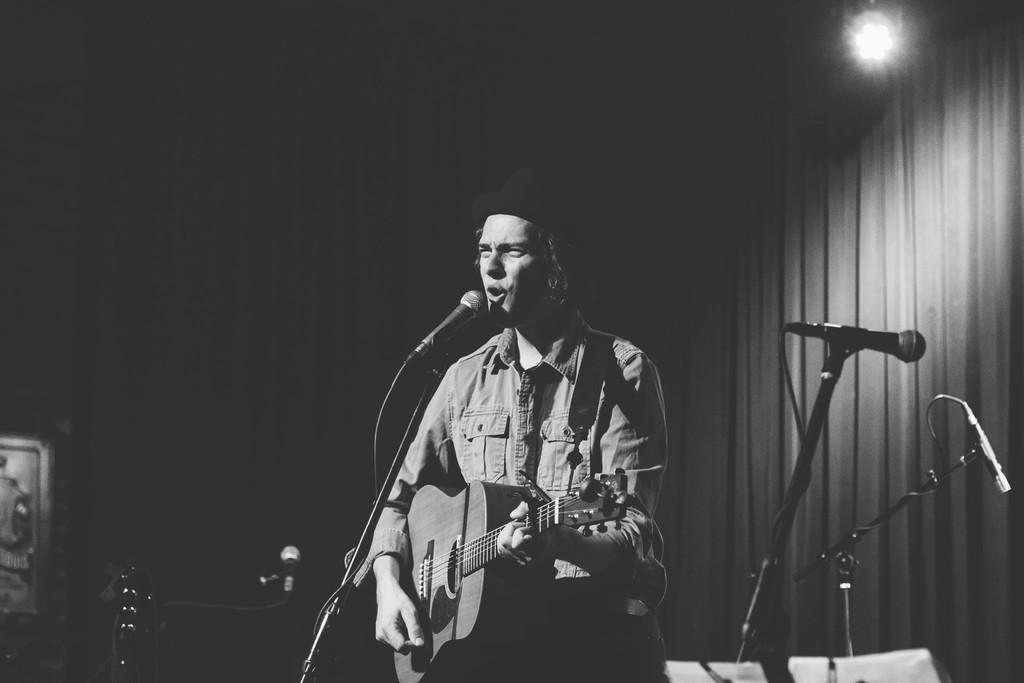What is the main subject of the image? There is a person in the image. What is the person doing in the image? The person is singing and playing a guitar. What type of cattle can be seen in the image? There are no cattle present in the image; it features a person singing and playing a guitar. What is the person using to stir the soup in the image? There is no soup or spoon present in the image. 